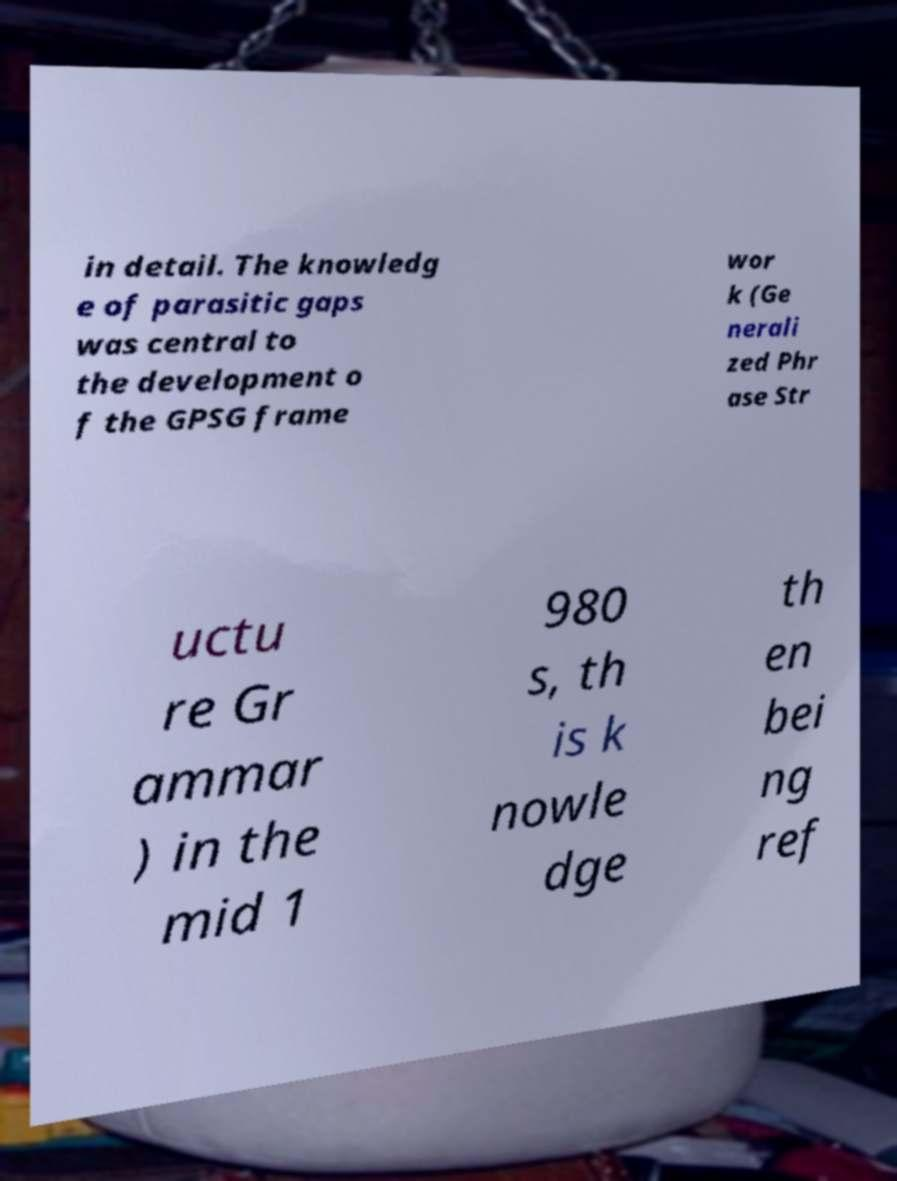Can you accurately transcribe the text from the provided image for me? in detail. The knowledg e of parasitic gaps was central to the development o f the GPSG frame wor k (Ge nerali zed Phr ase Str uctu re Gr ammar ) in the mid 1 980 s, th is k nowle dge th en bei ng ref 